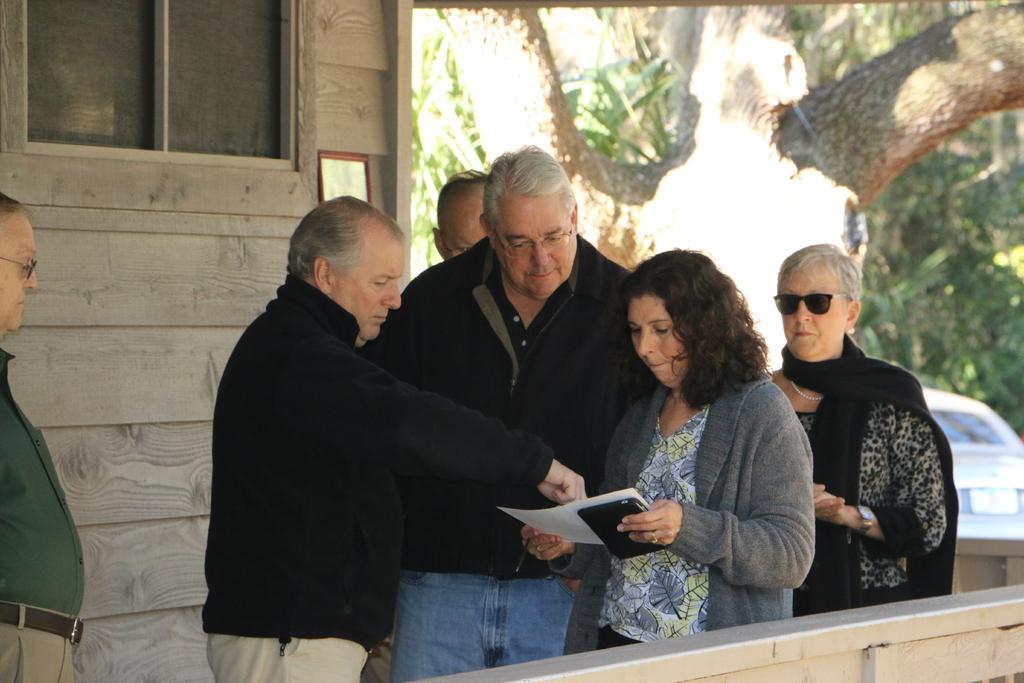How would you summarize this image in a sentence or two? In this image in the center there are persons standing. In the front there is a woman standing and holding a paper in her hand. In the background there are trees, there is a car and there is a wall and a window. In the front there is a wall. 